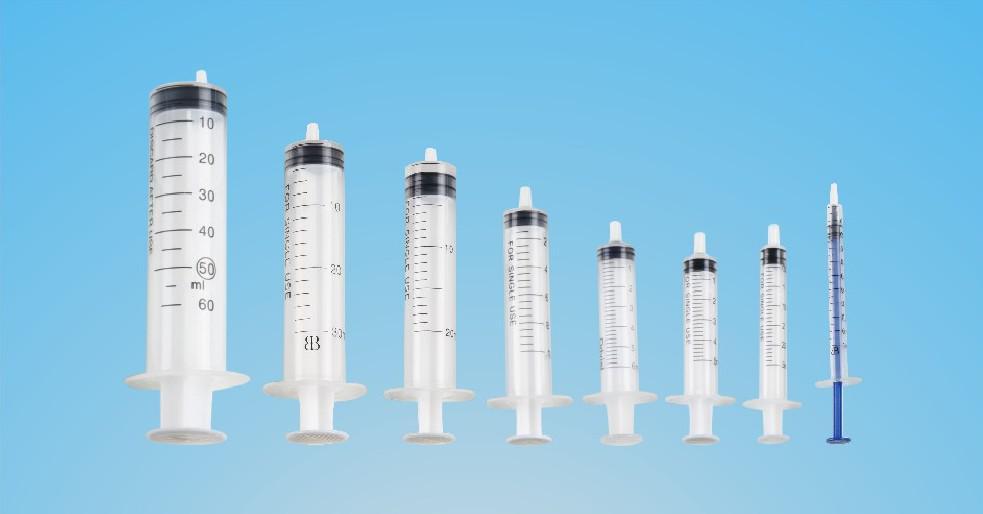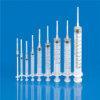The first image is the image on the left, the second image is the image on the right. Assess this claim about the two images: "One of the images has exactly 7 syringes.". Correct or not? Answer yes or no. No. 